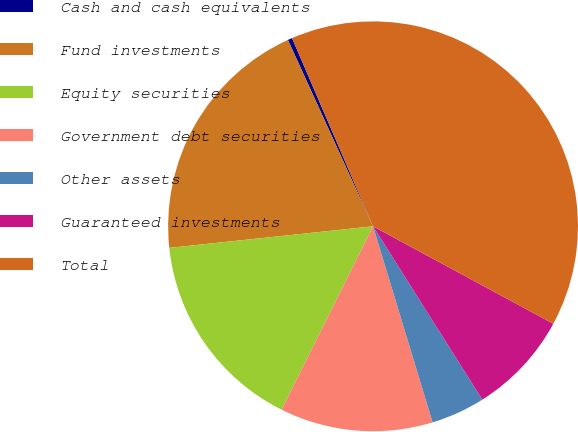Convert chart. <chart><loc_0><loc_0><loc_500><loc_500><pie_chart><fcel>Cash and cash equivalents<fcel>Fund investments<fcel>Equity securities<fcel>Government debt securities<fcel>Other assets<fcel>Guaranteed investments<fcel>Total<nl><fcel>0.35%<fcel>19.86%<fcel>15.96%<fcel>12.06%<fcel>4.26%<fcel>8.16%<fcel>39.36%<nl></chart> 